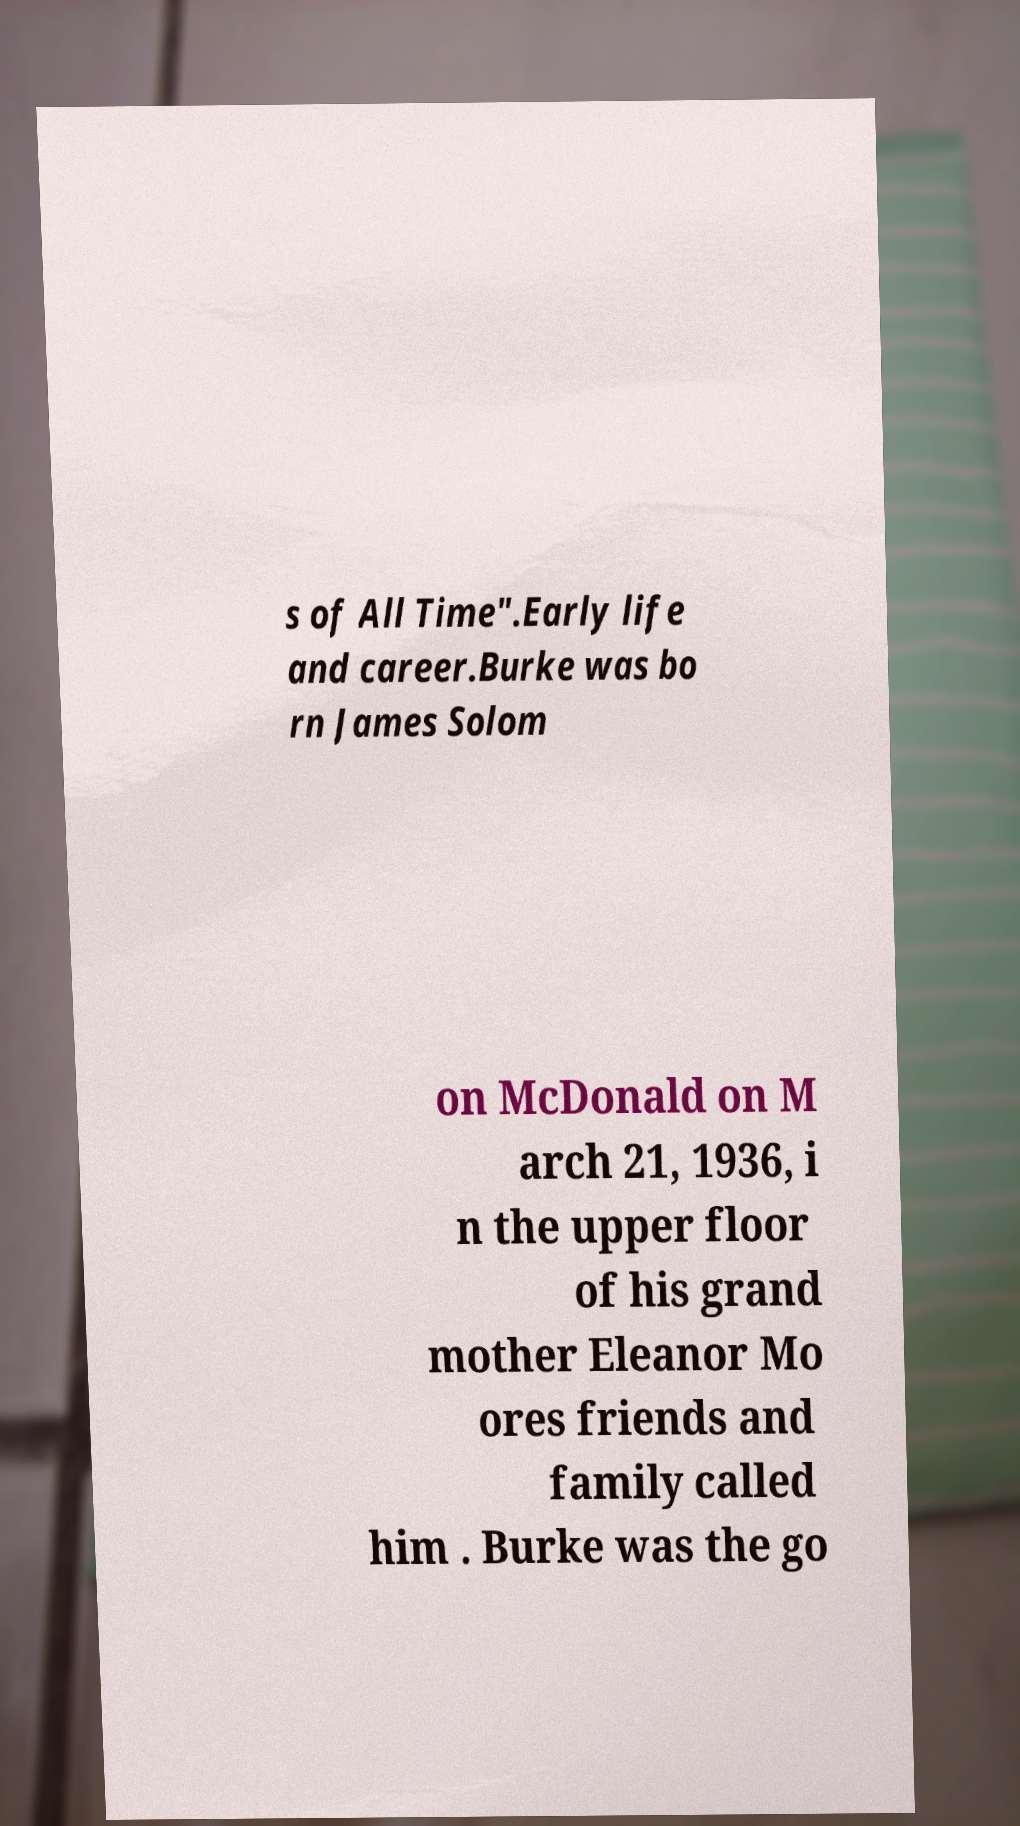What messages or text are displayed in this image? I need them in a readable, typed format. s of All Time".Early life and career.Burke was bo rn James Solom on McDonald on M arch 21, 1936, i n the upper floor of his grand mother Eleanor Mo ores friends and family called him . Burke was the go 